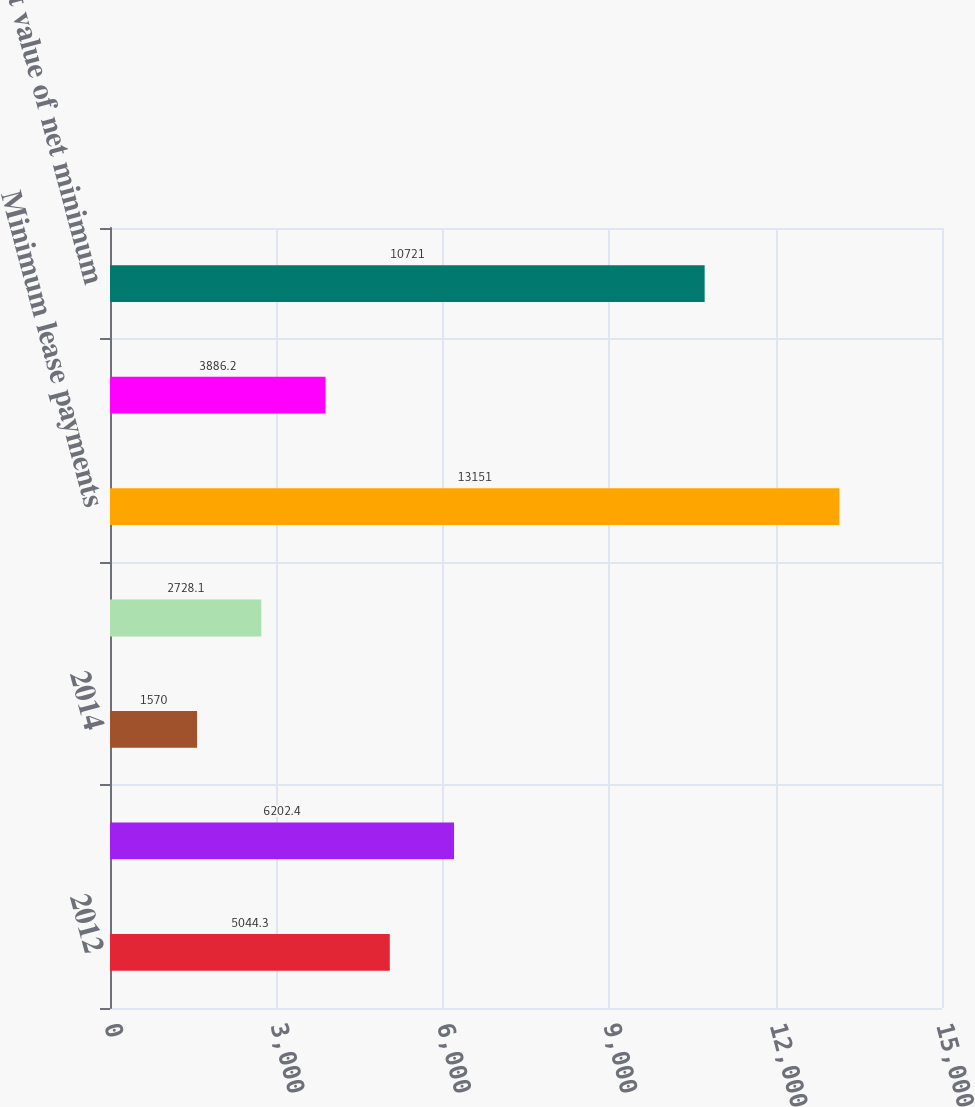Convert chart to OTSL. <chart><loc_0><loc_0><loc_500><loc_500><bar_chart><fcel>2012<fcel>2013<fcel>2014<fcel>2015<fcel>Minimum lease payments<fcel>Less Amount representing<fcel>Present value of net minimum<nl><fcel>5044.3<fcel>6202.4<fcel>1570<fcel>2728.1<fcel>13151<fcel>3886.2<fcel>10721<nl></chart> 